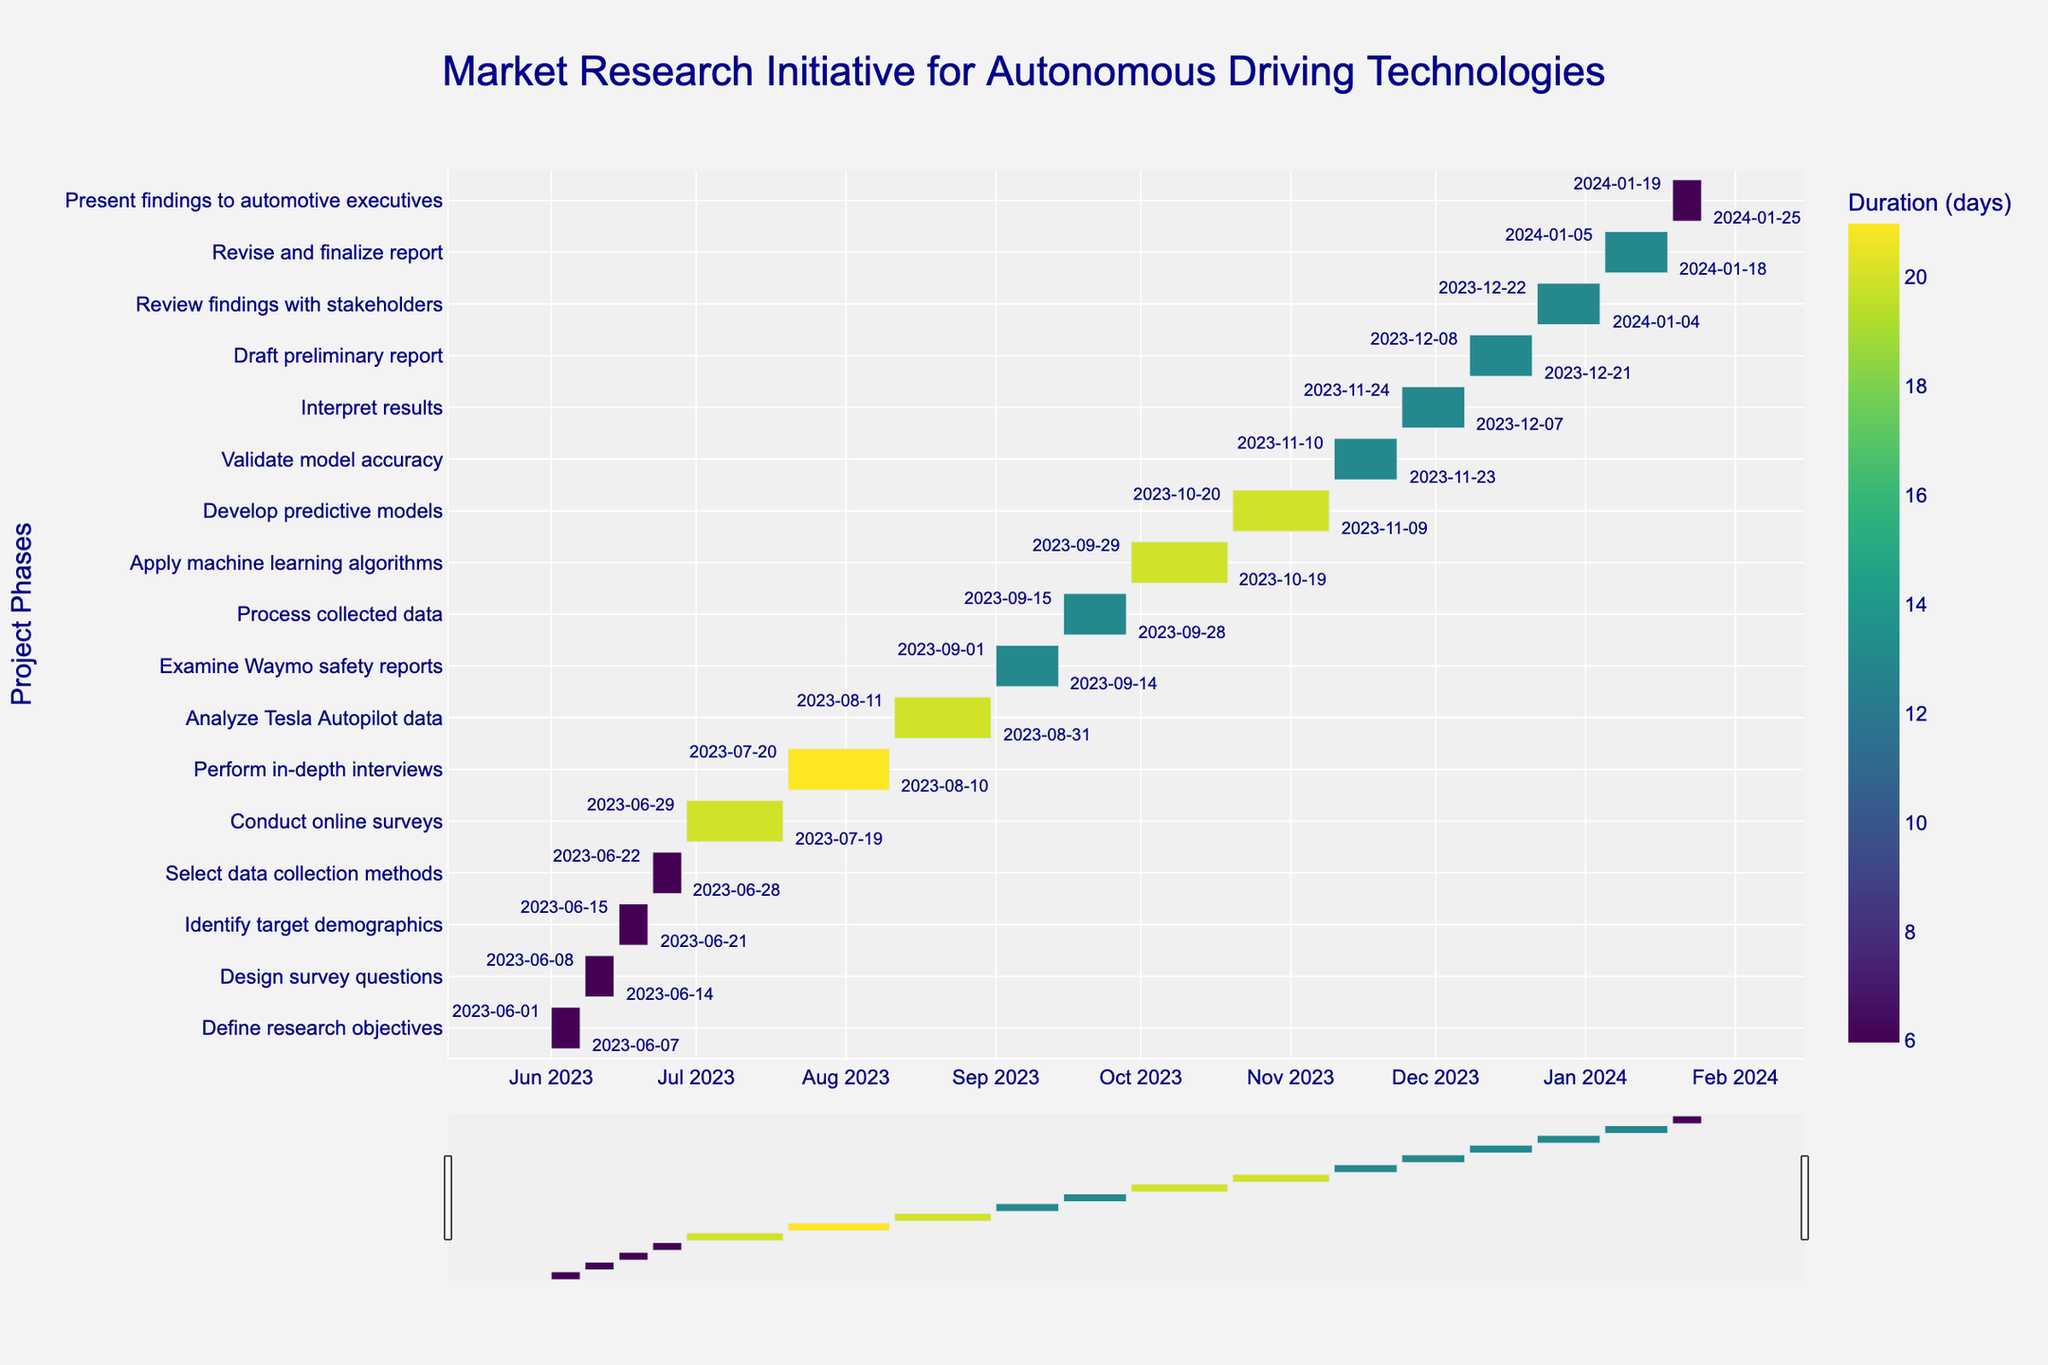What's the duration of the "Conduct online surveys" phase? Locate the "Conduct online surveys" task on the y-axis of the Gantt chart. The x-axis coordinates for this task indicate the start and end dates (2023-06-29 to 2023-07-19). Calculate the duration in days, which is the difference between the end date and the start date.
Answer: 21 days What is the overall time span for the entire market research initiative? Check the earliest start date and the latest end date among all tasks on the Gantt chart. The earliest start date is 2023-06-01, and the latest end date is 2024-01-25. Calculate the time span by finding the difference between these two dates.
Answer: From 2023-06-01 to 2024-01-25 Which task has the longest duration? Identify the task with the longest bar along the x-axis. Each bar's length corresponds to the task's duration, with longer bars indicating longer durations.
Answer: Perform in-depth interviews What two consecutive tasks have the shortest combined duration? Calculate the durations for each task and find consecutive tasks by their start and end dates. Sum the durations for each pair of consecutive tasks and determine which pair has the smallest sum.
Answer: Define research objectives and Design survey questions How many tasks are scheduled to end in November 2023? Examine the end dates for all tasks and count how many end between 2023-11-01 and 2023-11-30.
Answer: 3 tasks During which month does the "Analyze Tesla Autopilot data" task occur entirely? Check the start and end dates for the "Analyze Tesla Autopilot data" task. Both dates need to fall within the same month on the Gantt chart.
Answer: August 2023 What is the duration difference between "Analyze Tesla Autopilot data" and "Examine Waymo safety reports"? Determine the duration of each task by subtracting the start date from the end date for both tasks. Subtract the shorter duration from the longer duration.
Answer: 7 days Which phase directly follows "Review findings with stakeholders"? Identify the task that starts immediately after the end of the "Review findings with stakeholders" phase by comparing the end date of this task with the start dates of others.
Answer: Revise and finalize report Are there any tasks that overlap in September 2023? Examine the tasks' start and end dates to see if any tasks have overlapping periods during September 2023 on the Gantt chart.
Answer: Yes How many days are spent on data analysis and modeling activities combined? Identify tasks related to data analysis and modeling ("Analyze Tesla Autopilot data," "Examine Waymo safety reports," "Process collected data," "Apply machine learning algorithms," "Develop predictive models," and "Validate model accuracy"). Sum their durations.
Answer: 86 days 